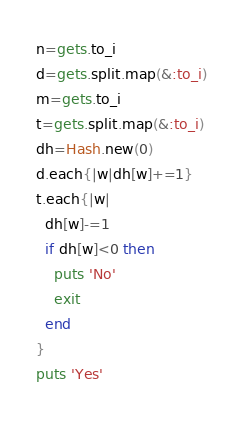Convert code to text. <code><loc_0><loc_0><loc_500><loc_500><_Ruby_>n=gets.to_i
d=gets.split.map(&:to_i)
m=gets.to_i
t=gets.split.map(&:to_i)
dh=Hash.new(0)
d.each{|w|dh[w]+=1}
t.each{|w|
  dh[w]-=1
  if dh[w]<0 then
    puts 'No'
    exit
  end
}
puts 'Yes'</code> 